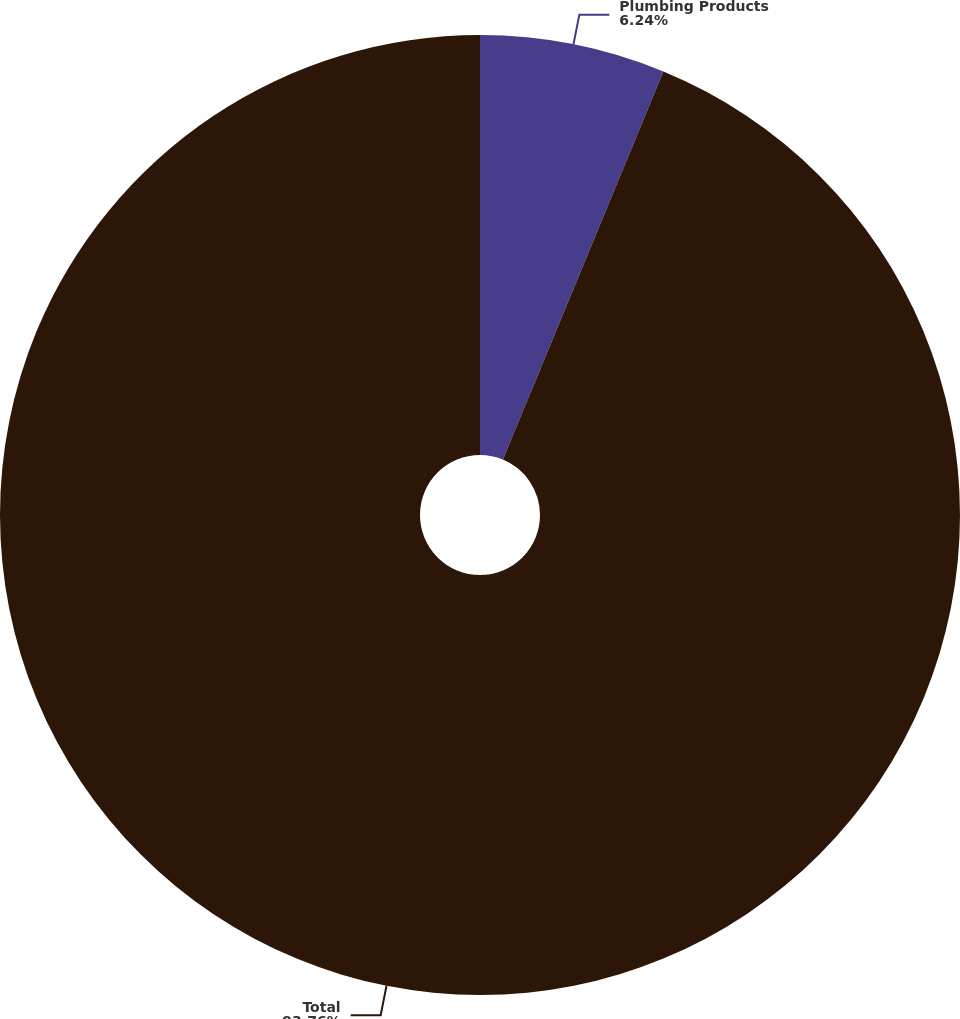Convert chart. <chart><loc_0><loc_0><loc_500><loc_500><pie_chart><fcel>Plumbing Products<fcel>Total<nl><fcel>6.24%<fcel>93.76%<nl></chart> 